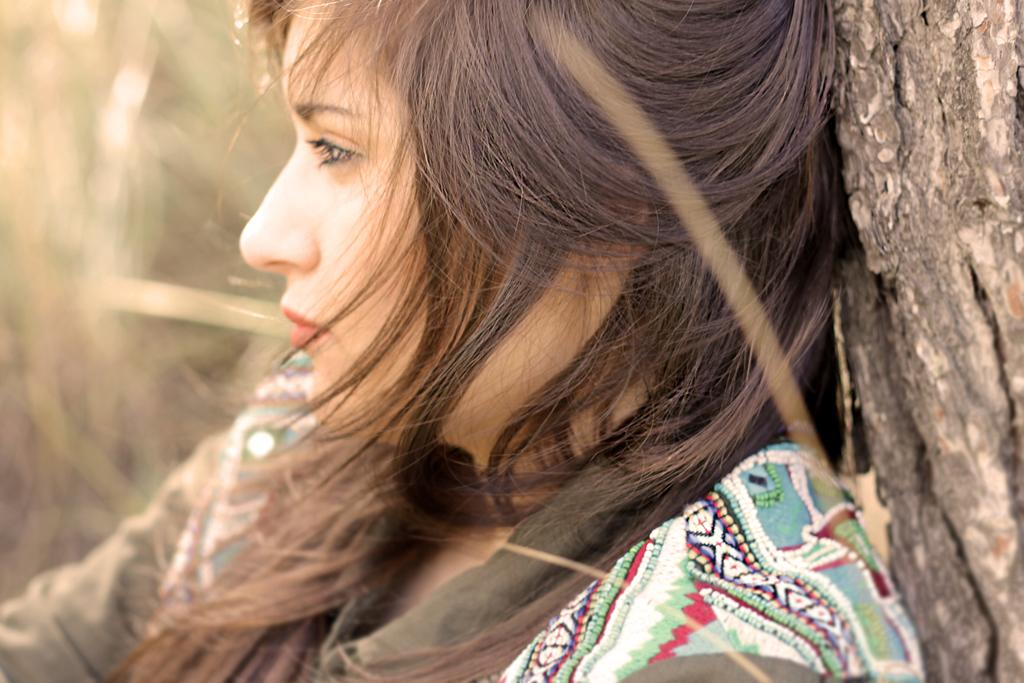What is the main subject of the picture? The main subject of the picture is an image of a woman. What is the woman doing in the image? The woman is sitting in a tree. Can you describe the background of the image? The background of the image is blurred. How many clocks are hanging from the branches of the tree in the image? There are no clocks visible in the image; the woman is sitting in a tree with a blurred background. 